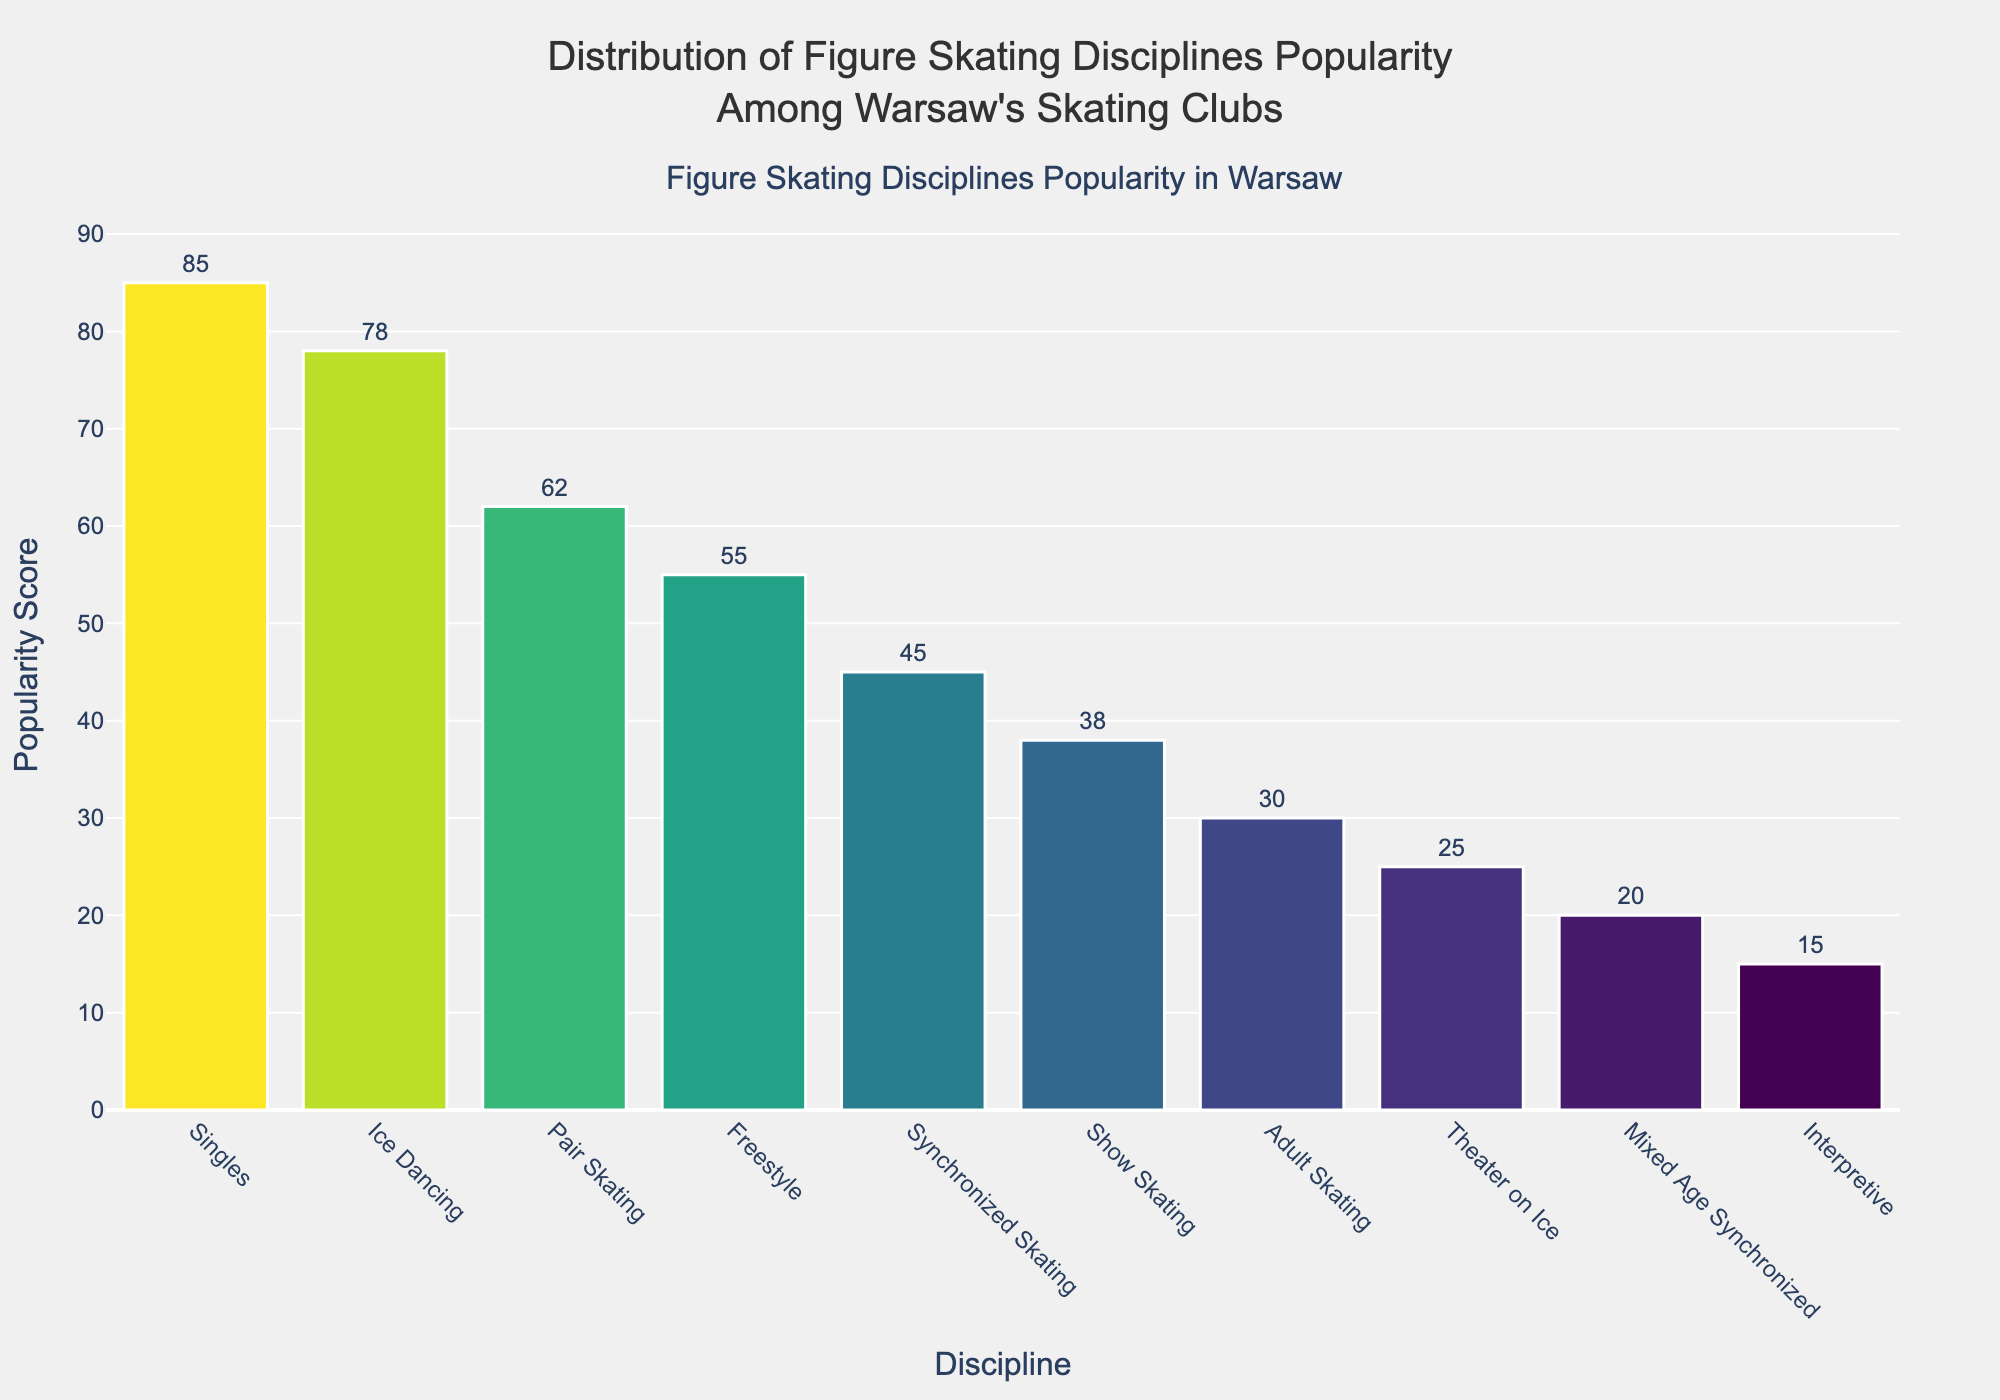Which discipline has the highest popularity score? The bar with the highest height represents the discipline with the highest popularity score. In this case, it's "Singles" with a score of 85.
Answer: Singles Which discipline has the lowest popularity score? The bar with the lowest height represents the discipline with the lowest popularity score. In this case, it's "Interpretive" with a score of 15.
Answer: Interpretive How much more popular is Singles compared to Pair Skating? The popularity score of Singles is 85, and the popularity score of Pair Skating is 62. The difference between them is 85 - 62 = 23.
Answer: 23 What is the total popularity score of the top three disciplines? The top three disciplines are Singles (85), Ice Dancing (78), and Pair Skating (62). Adding these scores together gives 85 + 78 + 62 = 225.
Answer: 225 What is the average popularity score of all disciplines? Sum all popularity scores and divide by the number of disciplines: (85 + 62 + 78 + 45 + 30 + 55 + 38 + 25 + 20 + 15) / 10 = 453 / 10 = 45.3
Answer: 45.3 Which disciplines have a popularity score greater than 50 but less than 80? Looking at the bars with scores between 50 and 80, the disciplines are Pair Skating (62), Ice Dancing (78), and Freestyle (55).
Answer: Pair Skating, Ice Dancing, Freestyle How does the popularity of Ice Dancing compare to Synchronized Skating? The popularity score of Ice Dancing is 78, and for Synchronized Skating, it is 45. Ice Dancing is 78 - 45 = 33 points more popular than Synchronized Skating.
Answer: 33 What's the combined popularity score of Adult Skating, Show Skating, and Theater on Ice? Add the popularity scores of Adult Skating (30), Show Skating (38), and Theater on Ice (25): 30 + 38 + 25 = 93.
Answer: 93 Which discipline has a similar popularity score to Freestyle? Show Skating has a popularity score close to Freestyle's score of 55.
Answer: Show Skating How many disciplines have a popularity score below 40? Count the bars with heights corresponding to scores below 40: Adult Skating (30), Show Skating (38), Theater on Ice (25), Mixed Age Synchronized (20), and Interpretive (15), which totals 5 disciplines.
Answer: 5 